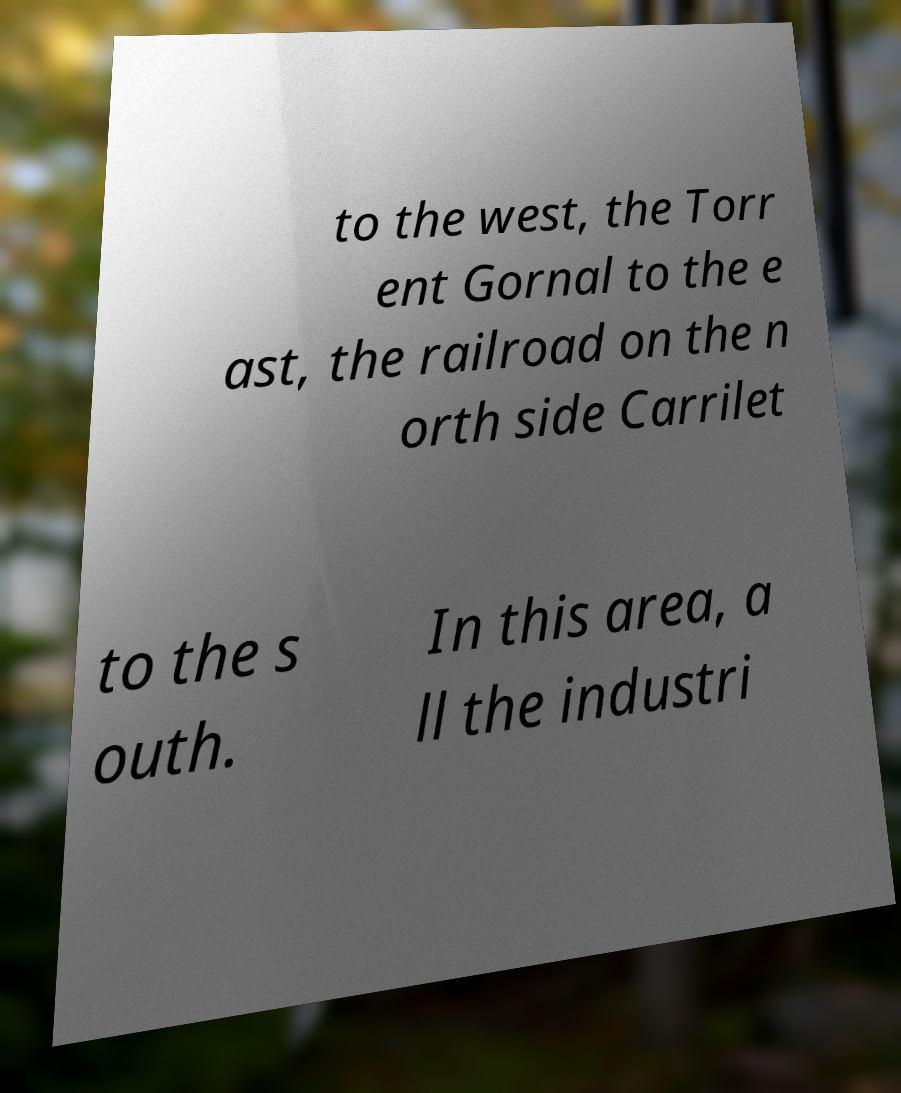Please identify and transcribe the text found in this image. to the west, the Torr ent Gornal to the e ast, the railroad on the n orth side Carrilet to the s outh. In this area, a ll the industri 